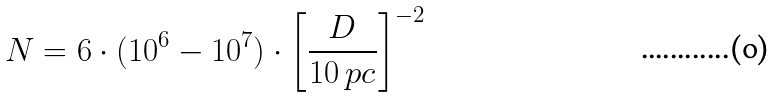<formula> <loc_0><loc_0><loc_500><loc_500>N = 6 \cdot ( 1 0 ^ { 6 } - 1 0 ^ { 7 } ) \cdot \left [ \frac { D } { 1 0 \ p c } \right ] ^ { - 2 }</formula> 